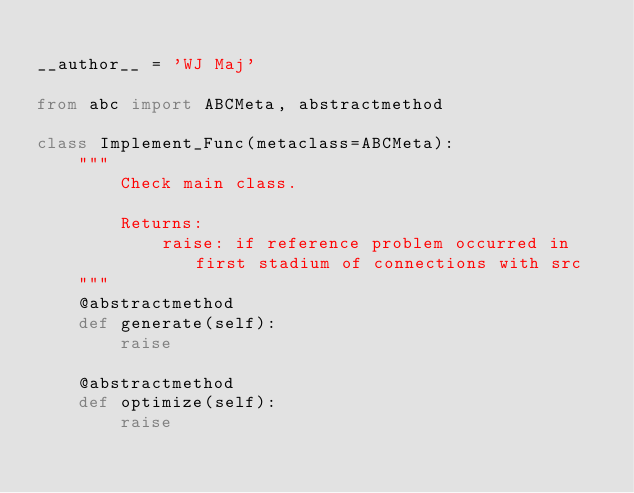<code> <loc_0><loc_0><loc_500><loc_500><_Python_>
__author__ = 'WJ Maj'

from abc import ABCMeta, abstractmethod

class Implement_Func(metaclass=ABCMeta):
    """
        Check main class.
        
        Returns:
            raise: if reference problem occurred in first stadium of connections with src
    """    
    @abstractmethod
    def generate(self):
        raise

    @abstractmethod
    def optimize(self):
        raise

</code> 